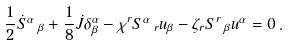Convert formula to latex. <formula><loc_0><loc_0><loc_500><loc_500>\frac { 1 } { 2 } \dot { S } ^ { \alpha } \, _ { \beta } + \frac { 1 } { 8 } \dot { J } \delta ^ { \alpha } _ { \beta } - \chi ^ { r } S ^ { \alpha } \, _ { r } u _ { \beta } - \zeta _ { r } S ^ { r } \, _ { \beta } u ^ { \alpha } = 0 \, .</formula> 